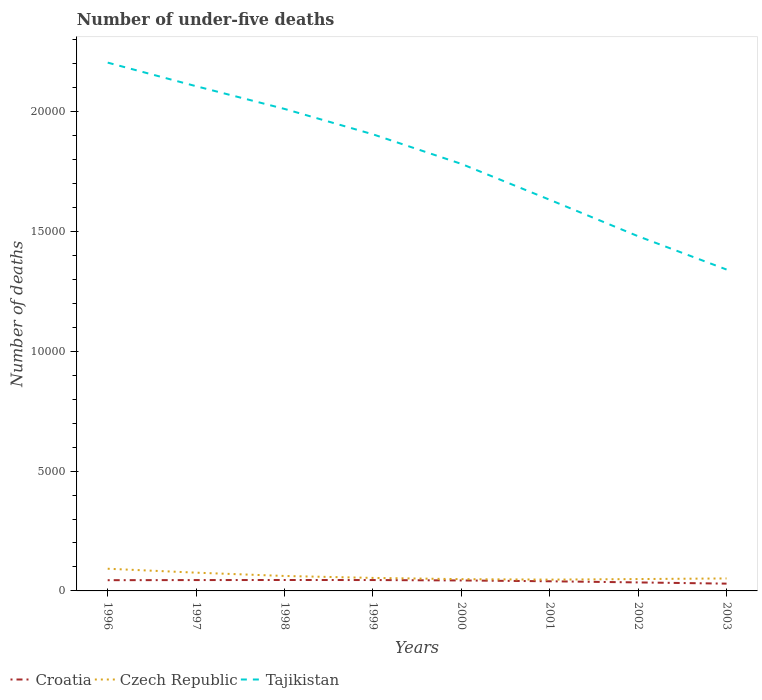How many different coloured lines are there?
Make the answer very short. 3. Does the line corresponding to Tajikistan intersect with the line corresponding to Czech Republic?
Offer a terse response. No. Is the number of lines equal to the number of legend labels?
Keep it short and to the point. Yes. Across all years, what is the maximum number of under-five deaths in Czech Republic?
Your answer should be compact. 472. What is the difference between the highest and the second highest number of under-five deaths in Tajikistan?
Give a very brief answer. 8635. What is the difference between the highest and the lowest number of under-five deaths in Tajikistan?
Your answer should be very brief. 4. How many lines are there?
Your response must be concise. 3. What is the difference between two consecutive major ticks on the Y-axis?
Offer a terse response. 5000. Does the graph contain any zero values?
Make the answer very short. No. Does the graph contain grids?
Make the answer very short. No. Where does the legend appear in the graph?
Ensure brevity in your answer.  Bottom left. How many legend labels are there?
Your answer should be very brief. 3. What is the title of the graph?
Keep it short and to the point. Number of under-five deaths. Does "Ghana" appear as one of the legend labels in the graph?
Provide a short and direct response. No. What is the label or title of the Y-axis?
Ensure brevity in your answer.  Number of deaths. What is the Number of deaths of Croatia in 1996?
Offer a terse response. 448. What is the Number of deaths of Czech Republic in 1996?
Your answer should be very brief. 926. What is the Number of deaths of Tajikistan in 1996?
Offer a terse response. 2.20e+04. What is the Number of deaths of Croatia in 1997?
Your answer should be compact. 453. What is the Number of deaths of Czech Republic in 1997?
Provide a short and direct response. 762. What is the Number of deaths of Tajikistan in 1997?
Provide a succinct answer. 2.11e+04. What is the Number of deaths in Croatia in 1998?
Your answer should be very brief. 456. What is the Number of deaths of Czech Republic in 1998?
Your answer should be compact. 624. What is the Number of deaths of Tajikistan in 1998?
Offer a terse response. 2.01e+04. What is the Number of deaths of Croatia in 1999?
Your answer should be compact. 454. What is the Number of deaths of Czech Republic in 1999?
Your answer should be very brief. 543. What is the Number of deaths in Tajikistan in 1999?
Give a very brief answer. 1.91e+04. What is the Number of deaths in Croatia in 2000?
Ensure brevity in your answer.  437. What is the Number of deaths of Czech Republic in 2000?
Offer a terse response. 491. What is the Number of deaths in Tajikistan in 2000?
Provide a succinct answer. 1.78e+04. What is the Number of deaths of Croatia in 2001?
Provide a short and direct response. 403. What is the Number of deaths in Czech Republic in 2001?
Keep it short and to the point. 472. What is the Number of deaths of Tajikistan in 2001?
Ensure brevity in your answer.  1.63e+04. What is the Number of deaths in Croatia in 2002?
Your answer should be compact. 355. What is the Number of deaths of Czech Republic in 2002?
Your response must be concise. 495. What is the Number of deaths in Tajikistan in 2002?
Your response must be concise. 1.48e+04. What is the Number of deaths in Croatia in 2003?
Provide a succinct answer. 304. What is the Number of deaths of Czech Republic in 2003?
Offer a very short reply. 521. What is the Number of deaths in Tajikistan in 2003?
Offer a very short reply. 1.34e+04. Across all years, what is the maximum Number of deaths of Croatia?
Provide a short and direct response. 456. Across all years, what is the maximum Number of deaths of Czech Republic?
Give a very brief answer. 926. Across all years, what is the maximum Number of deaths of Tajikistan?
Offer a terse response. 2.20e+04. Across all years, what is the minimum Number of deaths of Croatia?
Give a very brief answer. 304. Across all years, what is the minimum Number of deaths of Czech Republic?
Offer a very short reply. 472. Across all years, what is the minimum Number of deaths in Tajikistan?
Provide a short and direct response. 1.34e+04. What is the total Number of deaths in Croatia in the graph?
Provide a short and direct response. 3310. What is the total Number of deaths in Czech Republic in the graph?
Your answer should be compact. 4834. What is the total Number of deaths of Tajikistan in the graph?
Give a very brief answer. 1.45e+05. What is the difference between the Number of deaths in Croatia in 1996 and that in 1997?
Ensure brevity in your answer.  -5. What is the difference between the Number of deaths of Czech Republic in 1996 and that in 1997?
Your answer should be compact. 164. What is the difference between the Number of deaths in Tajikistan in 1996 and that in 1997?
Keep it short and to the point. 984. What is the difference between the Number of deaths in Czech Republic in 1996 and that in 1998?
Offer a very short reply. 302. What is the difference between the Number of deaths in Tajikistan in 1996 and that in 1998?
Make the answer very short. 1932. What is the difference between the Number of deaths of Croatia in 1996 and that in 1999?
Your answer should be very brief. -6. What is the difference between the Number of deaths in Czech Republic in 1996 and that in 1999?
Offer a terse response. 383. What is the difference between the Number of deaths in Tajikistan in 1996 and that in 1999?
Keep it short and to the point. 2992. What is the difference between the Number of deaths in Czech Republic in 1996 and that in 2000?
Offer a terse response. 435. What is the difference between the Number of deaths of Tajikistan in 1996 and that in 2000?
Your answer should be very brief. 4226. What is the difference between the Number of deaths of Croatia in 1996 and that in 2001?
Keep it short and to the point. 45. What is the difference between the Number of deaths in Czech Republic in 1996 and that in 2001?
Provide a short and direct response. 454. What is the difference between the Number of deaths in Tajikistan in 1996 and that in 2001?
Provide a succinct answer. 5724. What is the difference between the Number of deaths in Croatia in 1996 and that in 2002?
Provide a succinct answer. 93. What is the difference between the Number of deaths in Czech Republic in 1996 and that in 2002?
Make the answer very short. 431. What is the difference between the Number of deaths of Tajikistan in 1996 and that in 2002?
Ensure brevity in your answer.  7246. What is the difference between the Number of deaths in Croatia in 1996 and that in 2003?
Provide a succinct answer. 144. What is the difference between the Number of deaths of Czech Republic in 1996 and that in 2003?
Ensure brevity in your answer.  405. What is the difference between the Number of deaths in Tajikistan in 1996 and that in 2003?
Keep it short and to the point. 8635. What is the difference between the Number of deaths in Czech Republic in 1997 and that in 1998?
Give a very brief answer. 138. What is the difference between the Number of deaths in Tajikistan in 1997 and that in 1998?
Keep it short and to the point. 948. What is the difference between the Number of deaths in Czech Republic in 1997 and that in 1999?
Make the answer very short. 219. What is the difference between the Number of deaths in Tajikistan in 1997 and that in 1999?
Give a very brief answer. 2008. What is the difference between the Number of deaths of Czech Republic in 1997 and that in 2000?
Offer a terse response. 271. What is the difference between the Number of deaths in Tajikistan in 1997 and that in 2000?
Your response must be concise. 3242. What is the difference between the Number of deaths of Croatia in 1997 and that in 2001?
Provide a short and direct response. 50. What is the difference between the Number of deaths of Czech Republic in 1997 and that in 2001?
Provide a short and direct response. 290. What is the difference between the Number of deaths in Tajikistan in 1997 and that in 2001?
Your response must be concise. 4740. What is the difference between the Number of deaths of Czech Republic in 1997 and that in 2002?
Your response must be concise. 267. What is the difference between the Number of deaths in Tajikistan in 1997 and that in 2002?
Keep it short and to the point. 6262. What is the difference between the Number of deaths of Croatia in 1997 and that in 2003?
Keep it short and to the point. 149. What is the difference between the Number of deaths of Czech Republic in 1997 and that in 2003?
Give a very brief answer. 241. What is the difference between the Number of deaths in Tajikistan in 1997 and that in 2003?
Offer a very short reply. 7651. What is the difference between the Number of deaths of Croatia in 1998 and that in 1999?
Your answer should be very brief. 2. What is the difference between the Number of deaths in Czech Republic in 1998 and that in 1999?
Your answer should be compact. 81. What is the difference between the Number of deaths in Tajikistan in 1998 and that in 1999?
Your answer should be very brief. 1060. What is the difference between the Number of deaths of Czech Republic in 1998 and that in 2000?
Provide a short and direct response. 133. What is the difference between the Number of deaths of Tajikistan in 1998 and that in 2000?
Your response must be concise. 2294. What is the difference between the Number of deaths of Czech Republic in 1998 and that in 2001?
Offer a terse response. 152. What is the difference between the Number of deaths of Tajikistan in 1998 and that in 2001?
Your answer should be compact. 3792. What is the difference between the Number of deaths of Croatia in 1998 and that in 2002?
Provide a succinct answer. 101. What is the difference between the Number of deaths in Czech Republic in 1998 and that in 2002?
Keep it short and to the point. 129. What is the difference between the Number of deaths in Tajikistan in 1998 and that in 2002?
Offer a terse response. 5314. What is the difference between the Number of deaths of Croatia in 1998 and that in 2003?
Give a very brief answer. 152. What is the difference between the Number of deaths in Czech Republic in 1998 and that in 2003?
Your answer should be very brief. 103. What is the difference between the Number of deaths in Tajikistan in 1998 and that in 2003?
Your answer should be very brief. 6703. What is the difference between the Number of deaths in Croatia in 1999 and that in 2000?
Your response must be concise. 17. What is the difference between the Number of deaths in Tajikistan in 1999 and that in 2000?
Ensure brevity in your answer.  1234. What is the difference between the Number of deaths in Croatia in 1999 and that in 2001?
Make the answer very short. 51. What is the difference between the Number of deaths in Czech Republic in 1999 and that in 2001?
Make the answer very short. 71. What is the difference between the Number of deaths in Tajikistan in 1999 and that in 2001?
Keep it short and to the point. 2732. What is the difference between the Number of deaths of Croatia in 1999 and that in 2002?
Give a very brief answer. 99. What is the difference between the Number of deaths in Czech Republic in 1999 and that in 2002?
Your response must be concise. 48. What is the difference between the Number of deaths of Tajikistan in 1999 and that in 2002?
Your answer should be very brief. 4254. What is the difference between the Number of deaths in Croatia in 1999 and that in 2003?
Your answer should be very brief. 150. What is the difference between the Number of deaths of Tajikistan in 1999 and that in 2003?
Your answer should be very brief. 5643. What is the difference between the Number of deaths in Croatia in 2000 and that in 2001?
Your answer should be very brief. 34. What is the difference between the Number of deaths in Czech Republic in 2000 and that in 2001?
Give a very brief answer. 19. What is the difference between the Number of deaths in Tajikistan in 2000 and that in 2001?
Provide a short and direct response. 1498. What is the difference between the Number of deaths of Croatia in 2000 and that in 2002?
Provide a short and direct response. 82. What is the difference between the Number of deaths of Tajikistan in 2000 and that in 2002?
Give a very brief answer. 3020. What is the difference between the Number of deaths in Croatia in 2000 and that in 2003?
Give a very brief answer. 133. What is the difference between the Number of deaths in Czech Republic in 2000 and that in 2003?
Your answer should be compact. -30. What is the difference between the Number of deaths of Tajikistan in 2000 and that in 2003?
Give a very brief answer. 4409. What is the difference between the Number of deaths in Czech Republic in 2001 and that in 2002?
Keep it short and to the point. -23. What is the difference between the Number of deaths of Tajikistan in 2001 and that in 2002?
Your answer should be very brief. 1522. What is the difference between the Number of deaths in Croatia in 2001 and that in 2003?
Provide a succinct answer. 99. What is the difference between the Number of deaths of Czech Republic in 2001 and that in 2003?
Provide a short and direct response. -49. What is the difference between the Number of deaths of Tajikistan in 2001 and that in 2003?
Keep it short and to the point. 2911. What is the difference between the Number of deaths in Tajikistan in 2002 and that in 2003?
Offer a very short reply. 1389. What is the difference between the Number of deaths in Croatia in 1996 and the Number of deaths in Czech Republic in 1997?
Your answer should be very brief. -314. What is the difference between the Number of deaths in Croatia in 1996 and the Number of deaths in Tajikistan in 1997?
Your answer should be very brief. -2.06e+04. What is the difference between the Number of deaths in Czech Republic in 1996 and the Number of deaths in Tajikistan in 1997?
Your response must be concise. -2.01e+04. What is the difference between the Number of deaths of Croatia in 1996 and the Number of deaths of Czech Republic in 1998?
Your response must be concise. -176. What is the difference between the Number of deaths of Croatia in 1996 and the Number of deaths of Tajikistan in 1998?
Keep it short and to the point. -1.97e+04. What is the difference between the Number of deaths in Czech Republic in 1996 and the Number of deaths in Tajikistan in 1998?
Offer a terse response. -1.92e+04. What is the difference between the Number of deaths of Croatia in 1996 and the Number of deaths of Czech Republic in 1999?
Ensure brevity in your answer.  -95. What is the difference between the Number of deaths of Croatia in 1996 and the Number of deaths of Tajikistan in 1999?
Ensure brevity in your answer.  -1.86e+04. What is the difference between the Number of deaths of Czech Republic in 1996 and the Number of deaths of Tajikistan in 1999?
Keep it short and to the point. -1.81e+04. What is the difference between the Number of deaths of Croatia in 1996 and the Number of deaths of Czech Republic in 2000?
Keep it short and to the point. -43. What is the difference between the Number of deaths of Croatia in 1996 and the Number of deaths of Tajikistan in 2000?
Offer a terse response. -1.74e+04. What is the difference between the Number of deaths in Czech Republic in 1996 and the Number of deaths in Tajikistan in 2000?
Provide a succinct answer. -1.69e+04. What is the difference between the Number of deaths in Croatia in 1996 and the Number of deaths in Czech Republic in 2001?
Provide a succinct answer. -24. What is the difference between the Number of deaths in Croatia in 1996 and the Number of deaths in Tajikistan in 2001?
Your answer should be very brief. -1.59e+04. What is the difference between the Number of deaths in Czech Republic in 1996 and the Number of deaths in Tajikistan in 2001?
Make the answer very short. -1.54e+04. What is the difference between the Number of deaths of Croatia in 1996 and the Number of deaths of Czech Republic in 2002?
Give a very brief answer. -47. What is the difference between the Number of deaths in Croatia in 1996 and the Number of deaths in Tajikistan in 2002?
Keep it short and to the point. -1.44e+04. What is the difference between the Number of deaths in Czech Republic in 1996 and the Number of deaths in Tajikistan in 2002?
Make the answer very short. -1.39e+04. What is the difference between the Number of deaths of Croatia in 1996 and the Number of deaths of Czech Republic in 2003?
Keep it short and to the point. -73. What is the difference between the Number of deaths in Croatia in 1996 and the Number of deaths in Tajikistan in 2003?
Offer a terse response. -1.30e+04. What is the difference between the Number of deaths of Czech Republic in 1996 and the Number of deaths of Tajikistan in 2003?
Give a very brief answer. -1.25e+04. What is the difference between the Number of deaths in Croatia in 1997 and the Number of deaths in Czech Republic in 1998?
Give a very brief answer. -171. What is the difference between the Number of deaths of Croatia in 1997 and the Number of deaths of Tajikistan in 1998?
Your answer should be compact. -1.97e+04. What is the difference between the Number of deaths of Czech Republic in 1997 and the Number of deaths of Tajikistan in 1998?
Offer a very short reply. -1.94e+04. What is the difference between the Number of deaths in Croatia in 1997 and the Number of deaths in Czech Republic in 1999?
Keep it short and to the point. -90. What is the difference between the Number of deaths of Croatia in 1997 and the Number of deaths of Tajikistan in 1999?
Provide a short and direct response. -1.86e+04. What is the difference between the Number of deaths in Czech Republic in 1997 and the Number of deaths in Tajikistan in 1999?
Keep it short and to the point. -1.83e+04. What is the difference between the Number of deaths in Croatia in 1997 and the Number of deaths in Czech Republic in 2000?
Make the answer very short. -38. What is the difference between the Number of deaths of Croatia in 1997 and the Number of deaths of Tajikistan in 2000?
Make the answer very short. -1.74e+04. What is the difference between the Number of deaths in Czech Republic in 1997 and the Number of deaths in Tajikistan in 2000?
Give a very brief answer. -1.71e+04. What is the difference between the Number of deaths in Croatia in 1997 and the Number of deaths in Tajikistan in 2001?
Offer a terse response. -1.59e+04. What is the difference between the Number of deaths in Czech Republic in 1997 and the Number of deaths in Tajikistan in 2001?
Your answer should be compact. -1.56e+04. What is the difference between the Number of deaths in Croatia in 1997 and the Number of deaths in Czech Republic in 2002?
Provide a succinct answer. -42. What is the difference between the Number of deaths of Croatia in 1997 and the Number of deaths of Tajikistan in 2002?
Provide a succinct answer. -1.43e+04. What is the difference between the Number of deaths in Czech Republic in 1997 and the Number of deaths in Tajikistan in 2002?
Ensure brevity in your answer.  -1.40e+04. What is the difference between the Number of deaths of Croatia in 1997 and the Number of deaths of Czech Republic in 2003?
Make the answer very short. -68. What is the difference between the Number of deaths of Croatia in 1997 and the Number of deaths of Tajikistan in 2003?
Ensure brevity in your answer.  -1.30e+04. What is the difference between the Number of deaths in Czech Republic in 1997 and the Number of deaths in Tajikistan in 2003?
Your response must be concise. -1.26e+04. What is the difference between the Number of deaths of Croatia in 1998 and the Number of deaths of Czech Republic in 1999?
Keep it short and to the point. -87. What is the difference between the Number of deaths in Croatia in 1998 and the Number of deaths in Tajikistan in 1999?
Offer a very short reply. -1.86e+04. What is the difference between the Number of deaths in Czech Republic in 1998 and the Number of deaths in Tajikistan in 1999?
Your answer should be compact. -1.84e+04. What is the difference between the Number of deaths of Croatia in 1998 and the Number of deaths of Czech Republic in 2000?
Offer a very short reply. -35. What is the difference between the Number of deaths of Croatia in 1998 and the Number of deaths of Tajikistan in 2000?
Make the answer very short. -1.74e+04. What is the difference between the Number of deaths of Czech Republic in 1998 and the Number of deaths of Tajikistan in 2000?
Your response must be concise. -1.72e+04. What is the difference between the Number of deaths of Croatia in 1998 and the Number of deaths of Czech Republic in 2001?
Your answer should be compact. -16. What is the difference between the Number of deaths in Croatia in 1998 and the Number of deaths in Tajikistan in 2001?
Your answer should be compact. -1.59e+04. What is the difference between the Number of deaths of Czech Republic in 1998 and the Number of deaths of Tajikistan in 2001?
Your answer should be very brief. -1.57e+04. What is the difference between the Number of deaths of Croatia in 1998 and the Number of deaths of Czech Republic in 2002?
Make the answer very short. -39. What is the difference between the Number of deaths in Croatia in 1998 and the Number of deaths in Tajikistan in 2002?
Your response must be concise. -1.43e+04. What is the difference between the Number of deaths in Czech Republic in 1998 and the Number of deaths in Tajikistan in 2002?
Your response must be concise. -1.42e+04. What is the difference between the Number of deaths of Croatia in 1998 and the Number of deaths of Czech Republic in 2003?
Offer a very short reply. -65. What is the difference between the Number of deaths of Croatia in 1998 and the Number of deaths of Tajikistan in 2003?
Ensure brevity in your answer.  -1.30e+04. What is the difference between the Number of deaths of Czech Republic in 1998 and the Number of deaths of Tajikistan in 2003?
Offer a terse response. -1.28e+04. What is the difference between the Number of deaths of Croatia in 1999 and the Number of deaths of Czech Republic in 2000?
Make the answer very short. -37. What is the difference between the Number of deaths in Croatia in 1999 and the Number of deaths in Tajikistan in 2000?
Provide a succinct answer. -1.74e+04. What is the difference between the Number of deaths in Czech Republic in 1999 and the Number of deaths in Tajikistan in 2000?
Provide a short and direct response. -1.73e+04. What is the difference between the Number of deaths of Croatia in 1999 and the Number of deaths of Czech Republic in 2001?
Make the answer very short. -18. What is the difference between the Number of deaths in Croatia in 1999 and the Number of deaths in Tajikistan in 2001?
Give a very brief answer. -1.59e+04. What is the difference between the Number of deaths of Czech Republic in 1999 and the Number of deaths of Tajikistan in 2001?
Give a very brief answer. -1.58e+04. What is the difference between the Number of deaths of Croatia in 1999 and the Number of deaths of Czech Republic in 2002?
Make the answer very short. -41. What is the difference between the Number of deaths in Croatia in 1999 and the Number of deaths in Tajikistan in 2002?
Offer a very short reply. -1.43e+04. What is the difference between the Number of deaths in Czech Republic in 1999 and the Number of deaths in Tajikistan in 2002?
Ensure brevity in your answer.  -1.43e+04. What is the difference between the Number of deaths in Croatia in 1999 and the Number of deaths in Czech Republic in 2003?
Provide a succinct answer. -67. What is the difference between the Number of deaths in Croatia in 1999 and the Number of deaths in Tajikistan in 2003?
Ensure brevity in your answer.  -1.30e+04. What is the difference between the Number of deaths of Czech Republic in 1999 and the Number of deaths of Tajikistan in 2003?
Your answer should be very brief. -1.29e+04. What is the difference between the Number of deaths in Croatia in 2000 and the Number of deaths in Czech Republic in 2001?
Your answer should be compact. -35. What is the difference between the Number of deaths in Croatia in 2000 and the Number of deaths in Tajikistan in 2001?
Your answer should be very brief. -1.59e+04. What is the difference between the Number of deaths in Czech Republic in 2000 and the Number of deaths in Tajikistan in 2001?
Provide a short and direct response. -1.58e+04. What is the difference between the Number of deaths in Croatia in 2000 and the Number of deaths in Czech Republic in 2002?
Your answer should be compact. -58. What is the difference between the Number of deaths in Croatia in 2000 and the Number of deaths in Tajikistan in 2002?
Offer a terse response. -1.44e+04. What is the difference between the Number of deaths of Czech Republic in 2000 and the Number of deaths of Tajikistan in 2002?
Your answer should be compact. -1.43e+04. What is the difference between the Number of deaths of Croatia in 2000 and the Number of deaths of Czech Republic in 2003?
Offer a terse response. -84. What is the difference between the Number of deaths in Croatia in 2000 and the Number of deaths in Tajikistan in 2003?
Your response must be concise. -1.30e+04. What is the difference between the Number of deaths of Czech Republic in 2000 and the Number of deaths of Tajikistan in 2003?
Your answer should be very brief. -1.29e+04. What is the difference between the Number of deaths of Croatia in 2001 and the Number of deaths of Czech Republic in 2002?
Ensure brevity in your answer.  -92. What is the difference between the Number of deaths in Croatia in 2001 and the Number of deaths in Tajikistan in 2002?
Offer a very short reply. -1.44e+04. What is the difference between the Number of deaths in Czech Republic in 2001 and the Number of deaths in Tajikistan in 2002?
Provide a short and direct response. -1.43e+04. What is the difference between the Number of deaths of Croatia in 2001 and the Number of deaths of Czech Republic in 2003?
Give a very brief answer. -118. What is the difference between the Number of deaths of Croatia in 2001 and the Number of deaths of Tajikistan in 2003?
Offer a terse response. -1.30e+04. What is the difference between the Number of deaths of Czech Republic in 2001 and the Number of deaths of Tajikistan in 2003?
Ensure brevity in your answer.  -1.29e+04. What is the difference between the Number of deaths in Croatia in 2002 and the Number of deaths in Czech Republic in 2003?
Ensure brevity in your answer.  -166. What is the difference between the Number of deaths in Croatia in 2002 and the Number of deaths in Tajikistan in 2003?
Your response must be concise. -1.31e+04. What is the difference between the Number of deaths in Czech Republic in 2002 and the Number of deaths in Tajikistan in 2003?
Your answer should be very brief. -1.29e+04. What is the average Number of deaths in Croatia per year?
Give a very brief answer. 413.75. What is the average Number of deaths of Czech Republic per year?
Give a very brief answer. 604.25. What is the average Number of deaths of Tajikistan per year?
Offer a very short reply. 1.81e+04. In the year 1996, what is the difference between the Number of deaths in Croatia and Number of deaths in Czech Republic?
Ensure brevity in your answer.  -478. In the year 1996, what is the difference between the Number of deaths in Croatia and Number of deaths in Tajikistan?
Offer a very short reply. -2.16e+04. In the year 1996, what is the difference between the Number of deaths in Czech Republic and Number of deaths in Tajikistan?
Offer a terse response. -2.11e+04. In the year 1997, what is the difference between the Number of deaths in Croatia and Number of deaths in Czech Republic?
Provide a succinct answer. -309. In the year 1997, what is the difference between the Number of deaths in Croatia and Number of deaths in Tajikistan?
Keep it short and to the point. -2.06e+04. In the year 1997, what is the difference between the Number of deaths of Czech Republic and Number of deaths of Tajikistan?
Give a very brief answer. -2.03e+04. In the year 1998, what is the difference between the Number of deaths of Croatia and Number of deaths of Czech Republic?
Provide a short and direct response. -168. In the year 1998, what is the difference between the Number of deaths of Croatia and Number of deaths of Tajikistan?
Keep it short and to the point. -1.97e+04. In the year 1998, what is the difference between the Number of deaths in Czech Republic and Number of deaths in Tajikistan?
Your response must be concise. -1.95e+04. In the year 1999, what is the difference between the Number of deaths of Croatia and Number of deaths of Czech Republic?
Keep it short and to the point. -89. In the year 1999, what is the difference between the Number of deaths in Croatia and Number of deaths in Tajikistan?
Your answer should be very brief. -1.86e+04. In the year 1999, what is the difference between the Number of deaths of Czech Republic and Number of deaths of Tajikistan?
Ensure brevity in your answer.  -1.85e+04. In the year 2000, what is the difference between the Number of deaths of Croatia and Number of deaths of Czech Republic?
Ensure brevity in your answer.  -54. In the year 2000, what is the difference between the Number of deaths in Croatia and Number of deaths in Tajikistan?
Your answer should be very brief. -1.74e+04. In the year 2000, what is the difference between the Number of deaths in Czech Republic and Number of deaths in Tajikistan?
Offer a terse response. -1.73e+04. In the year 2001, what is the difference between the Number of deaths of Croatia and Number of deaths of Czech Republic?
Ensure brevity in your answer.  -69. In the year 2001, what is the difference between the Number of deaths in Croatia and Number of deaths in Tajikistan?
Provide a short and direct response. -1.59e+04. In the year 2001, what is the difference between the Number of deaths of Czech Republic and Number of deaths of Tajikistan?
Offer a very short reply. -1.59e+04. In the year 2002, what is the difference between the Number of deaths of Croatia and Number of deaths of Czech Republic?
Provide a short and direct response. -140. In the year 2002, what is the difference between the Number of deaths of Croatia and Number of deaths of Tajikistan?
Your answer should be very brief. -1.44e+04. In the year 2002, what is the difference between the Number of deaths of Czech Republic and Number of deaths of Tajikistan?
Provide a succinct answer. -1.43e+04. In the year 2003, what is the difference between the Number of deaths of Croatia and Number of deaths of Czech Republic?
Make the answer very short. -217. In the year 2003, what is the difference between the Number of deaths of Croatia and Number of deaths of Tajikistan?
Make the answer very short. -1.31e+04. In the year 2003, what is the difference between the Number of deaths of Czech Republic and Number of deaths of Tajikistan?
Keep it short and to the point. -1.29e+04. What is the ratio of the Number of deaths in Czech Republic in 1996 to that in 1997?
Your answer should be compact. 1.22. What is the ratio of the Number of deaths in Tajikistan in 1996 to that in 1997?
Your answer should be compact. 1.05. What is the ratio of the Number of deaths of Croatia in 1996 to that in 1998?
Give a very brief answer. 0.98. What is the ratio of the Number of deaths of Czech Republic in 1996 to that in 1998?
Your answer should be very brief. 1.48. What is the ratio of the Number of deaths in Tajikistan in 1996 to that in 1998?
Make the answer very short. 1.1. What is the ratio of the Number of deaths of Croatia in 1996 to that in 1999?
Provide a short and direct response. 0.99. What is the ratio of the Number of deaths in Czech Republic in 1996 to that in 1999?
Give a very brief answer. 1.71. What is the ratio of the Number of deaths of Tajikistan in 1996 to that in 1999?
Your answer should be compact. 1.16. What is the ratio of the Number of deaths in Croatia in 1996 to that in 2000?
Offer a very short reply. 1.03. What is the ratio of the Number of deaths of Czech Republic in 1996 to that in 2000?
Your response must be concise. 1.89. What is the ratio of the Number of deaths of Tajikistan in 1996 to that in 2000?
Provide a short and direct response. 1.24. What is the ratio of the Number of deaths of Croatia in 1996 to that in 2001?
Your answer should be very brief. 1.11. What is the ratio of the Number of deaths in Czech Republic in 1996 to that in 2001?
Your answer should be compact. 1.96. What is the ratio of the Number of deaths of Tajikistan in 1996 to that in 2001?
Offer a very short reply. 1.35. What is the ratio of the Number of deaths of Croatia in 1996 to that in 2002?
Give a very brief answer. 1.26. What is the ratio of the Number of deaths in Czech Republic in 1996 to that in 2002?
Provide a short and direct response. 1.87. What is the ratio of the Number of deaths of Tajikistan in 1996 to that in 2002?
Keep it short and to the point. 1.49. What is the ratio of the Number of deaths of Croatia in 1996 to that in 2003?
Give a very brief answer. 1.47. What is the ratio of the Number of deaths of Czech Republic in 1996 to that in 2003?
Your response must be concise. 1.78. What is the ratio of the Number of deaths of Tajikistan in 1996 to that in 2003?
Keep it short and to the point. 1.64. What is the ratio of the Number of deaths of Croatia in 1997 to that in 1998?
Give a very brief answer. 0.99. What is the ratio of the Number of deaths of Czech Republic in 1997 to that in 1998?
Keep it short and to the point. 1.22. What is the ratio of the Number of deaths in Tajikistan in 1997 to that in 1998?
Make the answer very short. 1.05. What is the ratio of the Number of deaths in Czech Republic in 1997 to that in 1999?
Your answer should be very brief. 1.4. What is the ratio of the Number of deaths in Tajikistan in 1997 to that in 1999?
Keep it short and to the point. 1.11. What is the ratio of the Number of deaths in Croatia in 1997 to that in 2000?
Offer a very short reply. 1.04. What is the ratio of the Number of deaths in Czech Republic in 1997 to that in 2000?
Give a very brief answer. 1.55. What is the ratio of the Number of deaths in Tajikistan in 1997 to that in 2000?
Give a very brief answer. 1.18. What is the ratio of the Number of deaths in Croatia in 1997 to that in 2001?
Provide a short and direct response. 1.12. What is the ratio of the Number of deaths in Czech Republic in 1997 to that in 2001?
Make the answer very short. 1.61. What is the ratio of the Number of deaths of Tajikistan in 1997 to that in 2001?
Your answer should be very brief. 1.29. What is the ratio of the Number of deaths in Croatia in 1997 to that in 2002?
Your answer should be very brief. 1.28. What is the ratio of the Number of deaths in Czech Republic in 1997 to that in 2002?
Give a very brief answer. 1.54. What is the ratio of the Number of deaths of Tajikistan in 1997 to that in 2002?
Your answer should be very brief. 1.42. What is the ratio of the Number of deaths in Croatia in 1997 to that in 2003?
Provide a succinct answer. 1.49. What is the ratio of the Number of deaths of Czech Republic in 1997 to that in 2003?
Provide a succinct answer. 1.46. What is the ratio of the Number of deaths in Tajikistan in 1997 to that in 2003?
Offer a terse response. 1.57. What is the ratio of the Number of deaths of Czech Republic in 1998 to that in 1999?
Make the answer very short. 1.15. What is the ratio of the Number of deaths of Tajikistan in 1998 to that in 1999?
Your answer should be compact. 1.06. What is the ratio of the Number of deaths in Croatia in 1998 to that in 2000?
Provide a short and direct response. 1.04. What is the ratio of the Number of deaths in Czech Republic in 1998 to that in 2000?
Your response must be concise. 1.27. What is the ratio of the Number of deaths in Tajikistan in 1998 to that in 2000?
Your response must be concise. 1.13. What is the ratio of the Number of deaths of Croatia in 1998 to that in 2001?
Offer a terse response. 1.13. What is the ratio of the Number of deaths of Czech Republic in 1998 to that in 2001?
Make the answer very short. 1.32. What is the ratio of the Number of deaths of Tajikistan in 1998 to that in 2001?
Your answer should be compact. 1.23. What is the ratio of the Number of deaths in Croatia in 1998 to that in 2002?
Ensure brevity in your answer.  1.28. What is the ratio of the Number of deaths of Czech Republic in 1998 to that in 2002?
Your response must be concise. 1.26. What is the ratio of the Number of deaths of Tajikistan in 1998 to that in 2002?
Provide a succinct answer. 1.36. What is the ratio of the Number of deaths of Czech Republic in 1998 to that in 2003?
Provide a succinct answer. 1.2. What is the ratio of the Number of deaths of Tajikistan in 1998 to that in 2003?
Ensure brevity in your answer.  1.5. What is the ratio of the Number of deaths of Croatia in 1999 to that in 2000?
Offer a very short reply. 1.04. What is the ratio of the Number of deaths in Czech Republic in 1999 to that in 2000?
Your answer should be very brief. 1.11. What is the ratio of the Number of deaths in Tajikistan in 1999 to that in 2000?
Offer a very short reply. 1.07. What is the ratio of the Number of deaths of Croatia in 1999 to that in 2001?
Ensure brevity in your answer.  1.13. What is the ratio of the Number of deaths in Czech Republic in 1999 to that in 2001?
Provide a short and direct response. 1.15. What is the ratio of the Number of deaths of Tajikistan in 1999 to that in 2001?
Give a very brief answer. 1.17. What is the ratio of the Number of deaths of Croatia in 1999 to that in 2002?
Your answer should be very brief. 1.28. What is the ratio of the Number of deaths of Czech Republic in 1999 to that in 2002?
Provide a short and direct response. 1.1. What is the ratio of the Number of deaths of Tajikistan in 1999 to that in 2002?
Keep it short and to the point. 1.29. What is the ratio of the Number of deaths of Croatia in 1999 to that in 2003?
Offer a terse response. 1.49. What is the ratio of the Number of deaths in Czech Republic in 1999 to that in 2003?
Ensure brevity in your answer.  1.04. What is the ratio of the Number of deaths of Tajikistan in 1999 to that in 2003?
Give a very brief answer. 1.42. What is the ratio of the Number of deaths of Croatia in 2000 to that in 2001?
Provide a succinct answer. 1.08. What is the ratio of the Number of deaths of Czech Republic in 2000 to that in 2001?
Provide a short and direct response. 1.04. What is the ratio of the Number of deaths of Tajikistan in 2000 to that in 2001?
Offer a very short reply. 1.09. What is the ratio of the Number of deaths in Croatia in 2000 to that in 2002?
Your answer should be very brief. 1.23. What is the ratio of the Number of deaths in Czech Republic in 2000 to that in 2002?
Provide a short and direct response. 0.99. What is the ratio of the Number of deaths of Tajikistan in 2000 to that in 2002?
Provide a succinct answer. 1.2. What is the ratio of the Number of deaths in Croatia in 2000 to that in 2003?
Provide a short and direct response. 1.44. What is the ratio of the Number of deaths in Czech Republic in 2000 to that in 2003?
Provide a succinct answer. 0.94. What is the ratio of the Number of deaths in Tajikistan in 2000 to that in 2003?
Your response must be concise. 1.33. What is the ratio of the Number of deaths in Croatia in 2001 to that in 2002?
Your response must be concise. 1.14. What is the ratio of the Number of deaths in Czech Republic in 2001 to that in 2002?
Provide a succinct answer. 0.95. What is the ratio of the Number of deaths in Tajikistan in 2001 to that in 2002?
Keep it short and to the point. 1.1. What is the ratio of the Number of deaths of Croatia in 2001 to that in 2003?
Ensure brevity in your answer.  1.33. What is the ratio of the Number of deaths of Czech Republic in 2001 to that in 2003?
Offer a terse response. 0.91. What is the ratio of the Number of deaths in Tajikistan in 2001 to that in 2003?
Provide a short and direct response. 1.22. What is the ratio of the Number of deaths in Croatia in 2002 to that in 2003?
Offer a terse response. 1.17. What is the ratio of the Number of deaths of Czech Republic in 2002 to that in 2003?
Provide a short and direct response. 0.95. What is the ratio of the Number of deaths of Tajikistan in 2002 to that in 2003?
Your answer should be compact. 1.1. What is the difference between the highest and the second highest Number of deaths in Croatia?
Ensure brevity in your answer.  2. What is the difference between the highest and the second highest Number of deaths in Czech Republic?
Give a very brief answer. 164. What is the difference between the highest and the second highest Number of deaths of Tajikistan?
Offer a very short reply. 984. What is the difference between the highest and the lowest Number of deaths in Croatia?
Your answer should be compact. 152. What is the difference between the highest and the lowest Number of deaths in Czech Republic?
Offer a very short reply. 454. What is the difference between the highest and the lowest Number of deaths of Tajikistan?
Your answer should be very brief. 8635. 